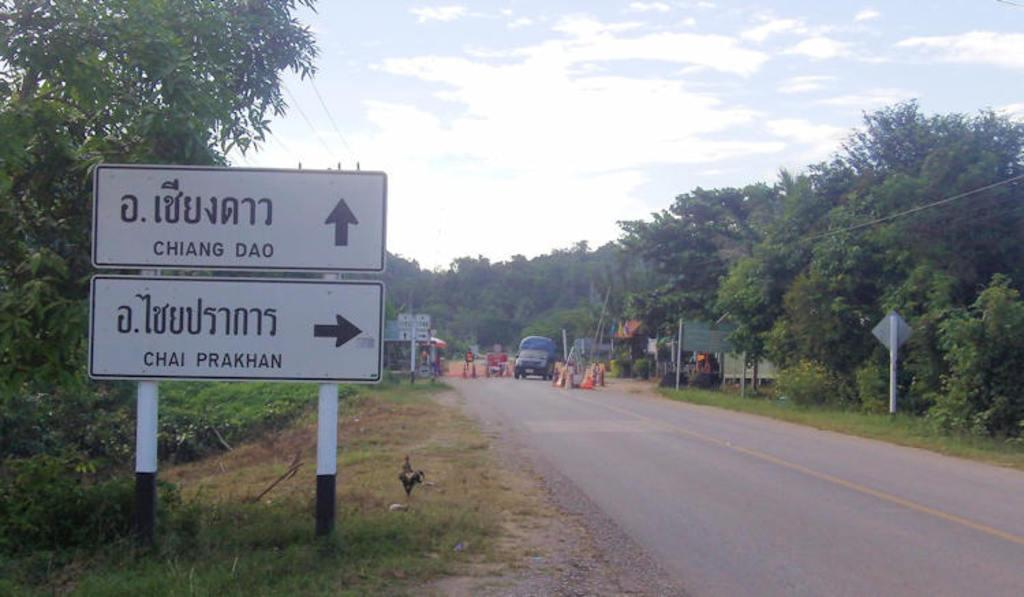What can be seen on poles in the image? There are boards on poles in the image. What type of terrain is visible in the image? There is grass visible in the image. What type of animal can be seen in the image? There is a bird in the image. What type of man-made structure is present in the image? There is a road in the image. What objects can be seen in the background of the image? In the background, there is a vehicle, traffic cones, boards and poles, plants, trees, wires, and the sky. What is the condition of the sky in the image? Clouds are present in the sky. What type of leaf is being used as a print for the bird's clothing in the image? There is no bird wearing clothing in the image, nor is there any mention of leaves being used as prints. 